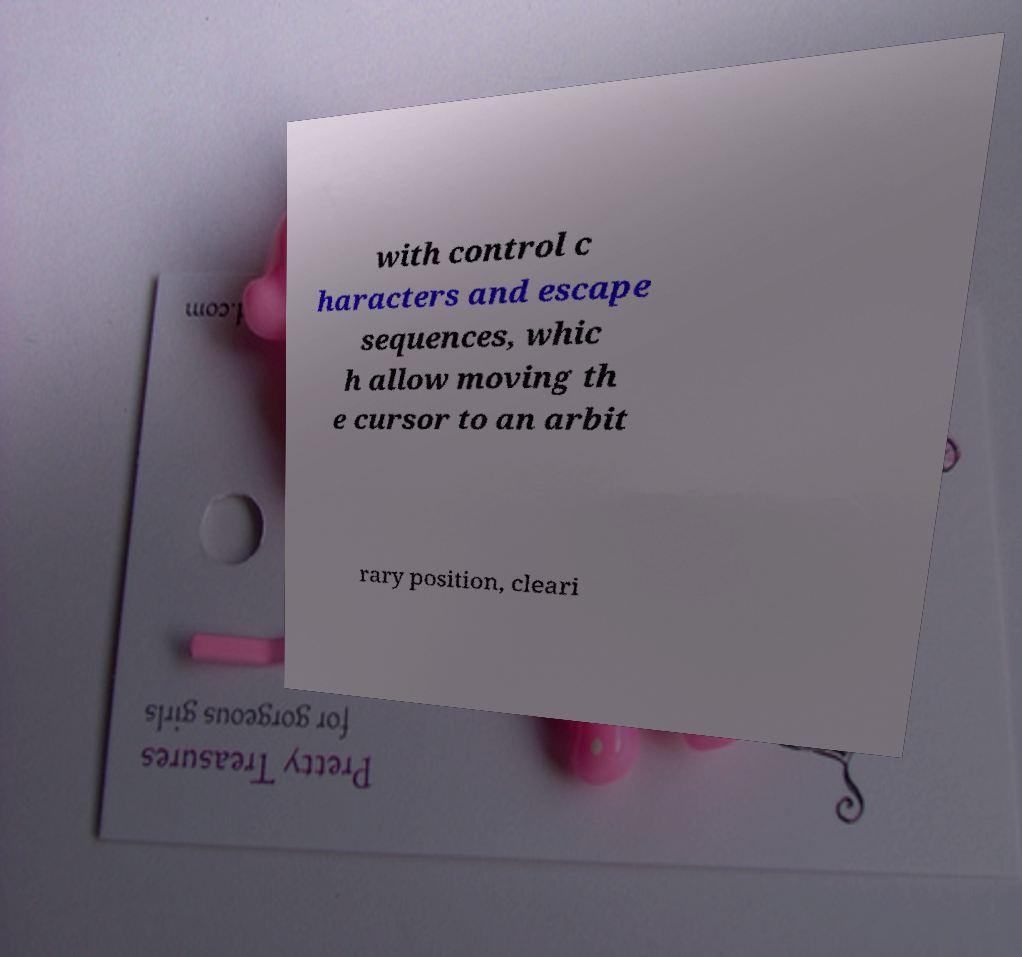For documentation purposes, I need the text within this image transcribed. Could you provide that? with control c haracters and escape sequences, whic h allow moving th e cursor to an arbit rary position, cleari 